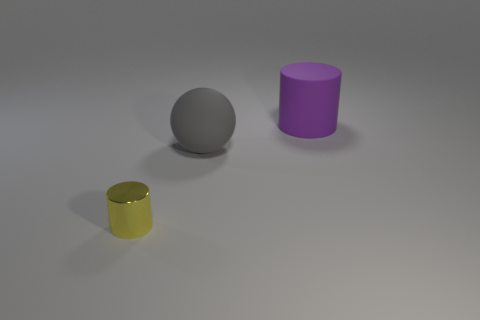Add 2 gray objects. How many objects exist? 5 Subtract all purple cylinders. How many cylinders are left? 1 Subtract all balls. How many objects are left? 2 Subtract all small red rubber cylinders. Subtract all large things. How many objects are left? 1 Add 1 small yellow things. How many small yellow things are left? 2 Add 2 matte spheres. How many matte spheres exist? 3 Subtract 0 brown cubes. How many objects are left? 3 Subtract all cyan spheres. Subtract all cyan cylinders. How many spheres are left? 1 